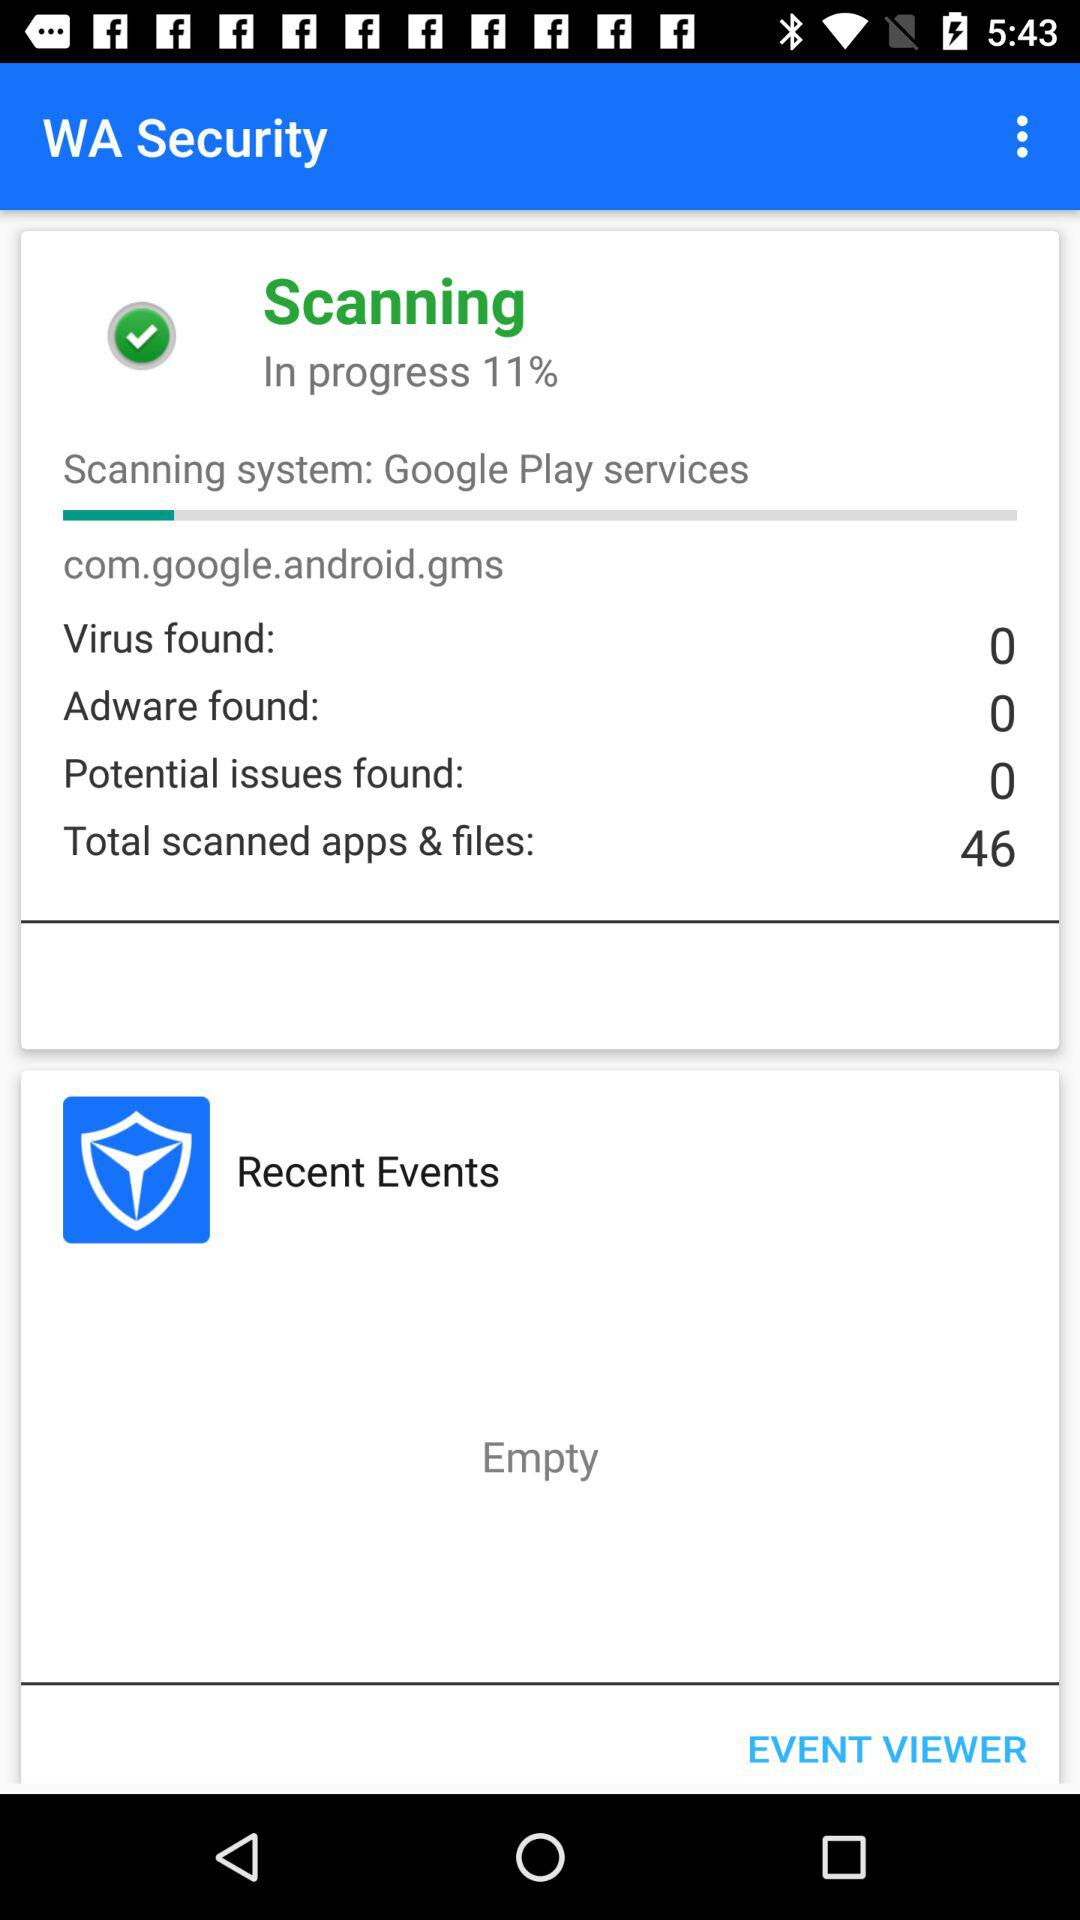How many more total scanned apps & files than virus were found?
Answer the question using a single word or phrase. 46 